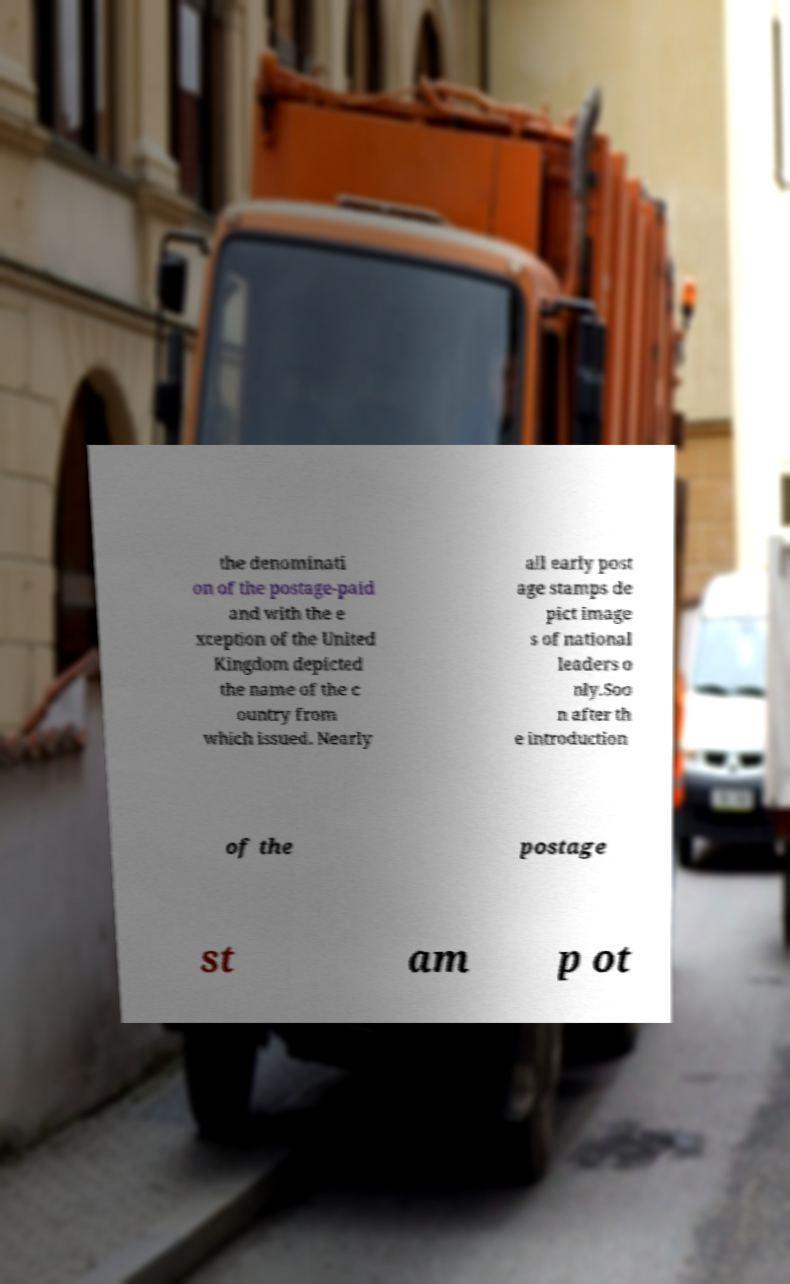Please read and relay the text visible in this image. What does it say? the denominati on of the postage-paid and with the e xception of the United Kingdom depicted the name of the c ountry from which issued. Nearly all early post age stamps de pict image s of national leaders o nly.Soo n after th e introduction of the postage st am p ot 